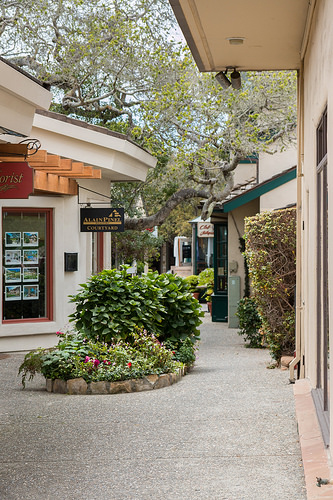<image>
Is there a building in front of the tree? Yes. The building is positioned in front of the tree, appearing closer to the camera viewpoint. 